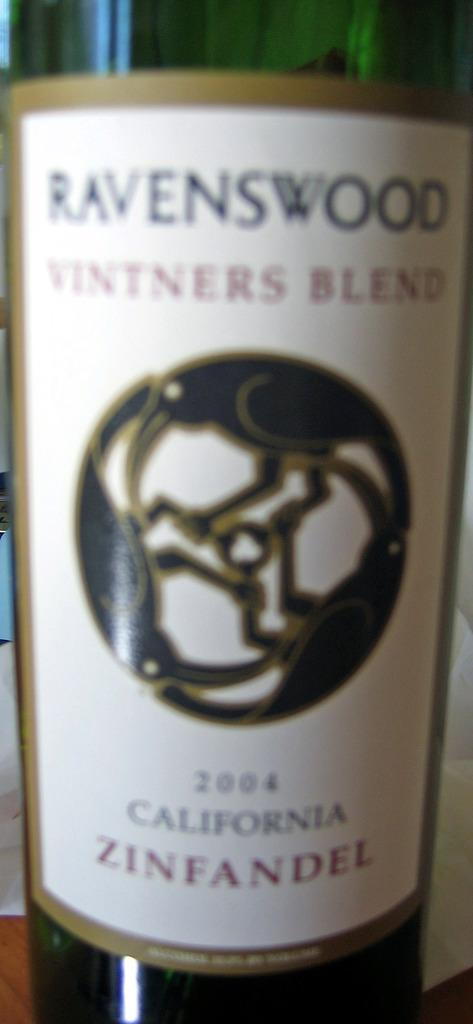<image>
Give a short and clear explanation of the subsequent image. The wine label is from a 2004 California Zinfandel. 